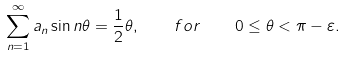<formula> <loc_0><loc_0><loc_500><loc_500>\sum _ { n = 1 } ^ { \infty } a _ { n } \sin n \theta = \frac { 1 } { 2 } \theta , \quad f o r \quad 0 \leq \theta < \pi - \varepsilon .</formula> 